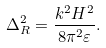<formula> <loc_0><loc_0><loc_500><loc_500>\Delta _ { R } ^ { 2 } = \frac { k ^ { 2 } H ^ { 2 } } { 8 \pi ^ { 2 } \varepsilon } .</formula> 